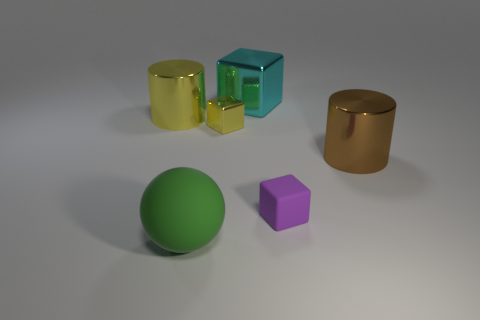Are there an equal number of cylinders that are on the left side of the rubber ball and brown rubber blocks?
Ensure brevity in your answer.  No. Is the green object made of the same material as the yellow cylinder?
Give a very brief answer. No. What size is the thing that is both in front of the big brown object and on the right side of the green object?
Make the answer very short. Small. How many matte objects are the same size as the brown cylinder?
Ensure brevity in your answer.  1. There is a yellow metallic thing that is on the right side of the metal cylinder on the left side of the large brown cylinder; what is its size?
Offer a terse response. Small. There is a tiny rubber thing right of the big green sphere; is it the same shape as the yellow metal thing to the left of the small yellow object?
Ensure brevity in your answer.  No. The thing that is both on the right side of the large cyan cube and behind the small purple rubber object is what color?
Give a very brief answer. Brown. Are there any metal things of the same color as the rubber sphere?
Your answer should be compact. No. There is a tiny thing that is in front of the small shiny cube; what is its color?
Offer a terse response. Purple. Are there any large brown cylinders in front of the small block that is to the right of the big cube?
Offer a very short reply. No. 